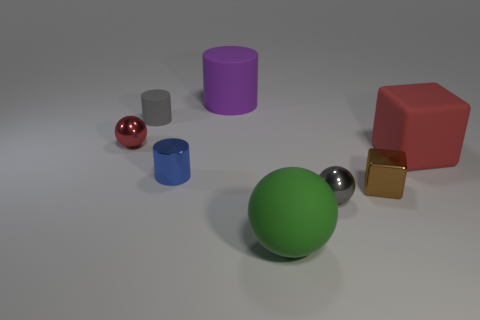Add 1 large cyan objects. How many objects exist? 9 Subtract all cylinders. How many objects are left? 5 Subtract 0 blue cubes. How many objects are left? 8 Subtract all gray shiny things. Subtract all tiny blue cylinders. How many objects are left? 6 Add 7 small rubber cylinders. How many small rubber cylinders are left? 8 Add 8 tiny blue metal cylinders. How many tiny blue metal cylinders exist? 9 